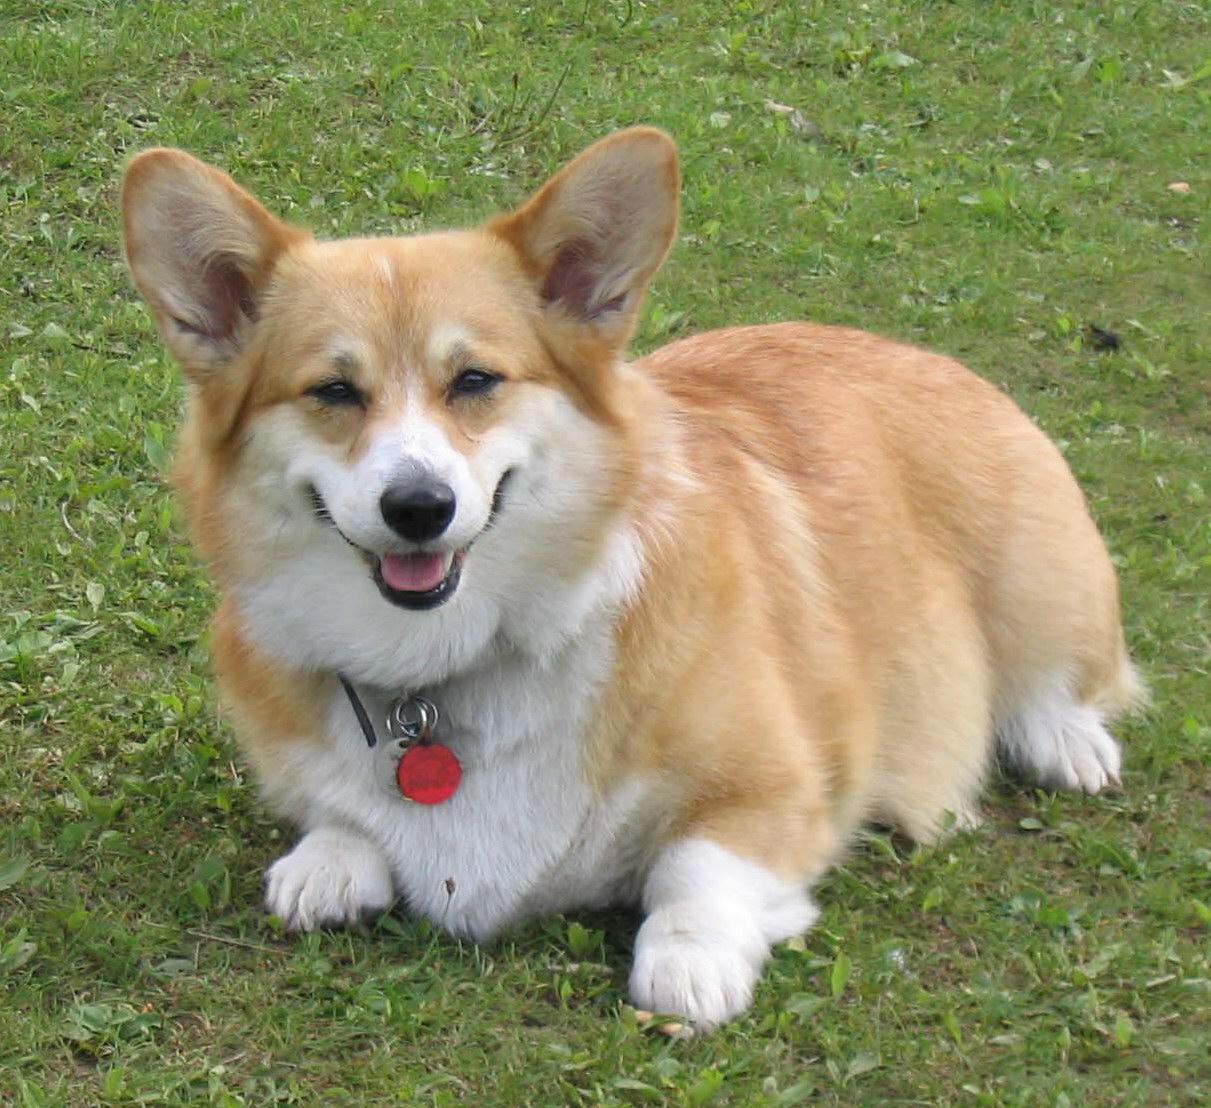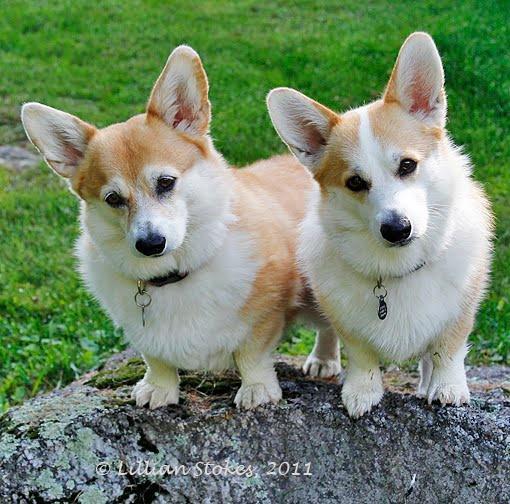The first image is the image on the left, the second image is the image on the right. For the images shown, is this caption "there is at least one dog with dog tags in the image pair" true? Answer yes or no. Yes. The first image is the image on the left, the second image is the image on the right. Given the left and right images, does the statement "Exactly one dog is pointed to the right." hold true? Answer yes or no. No. 